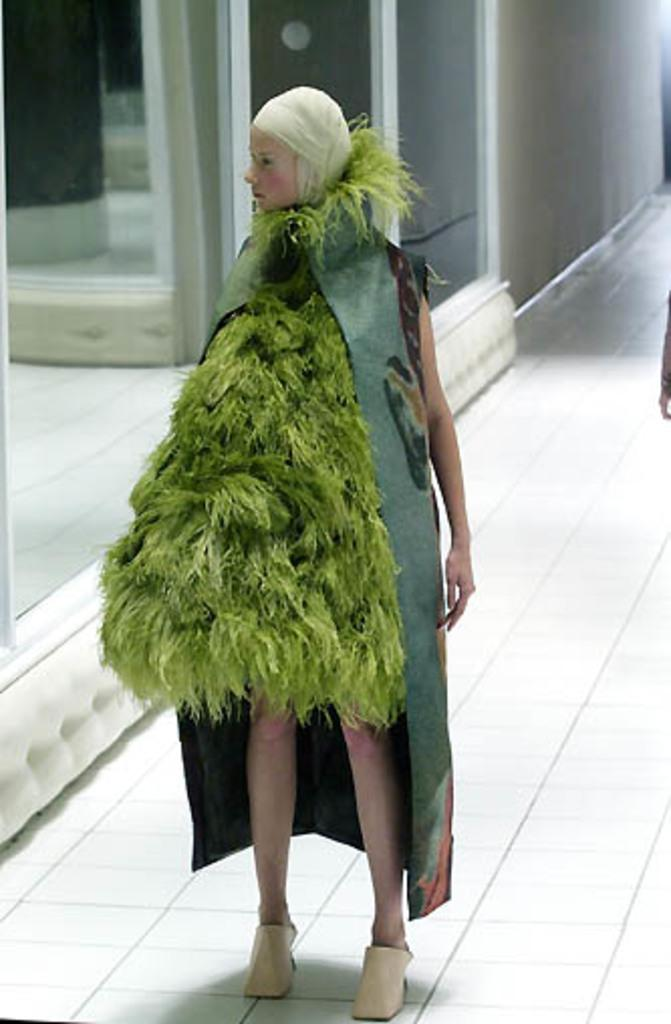Who is present in the image? There is a woman in the image. What is the woman doing in the image? The woman is standing on the floor. What is the woman wearing in the image? The woman is wearing a costume. What objects can be seen in the image besides the woman? There are mirrors and a wall in the image. How many goats are present in the image? There are no goats present in the image. What is the mass of the mirrors in the image? The mass of the mirrors cannot be determined from the image alone. 